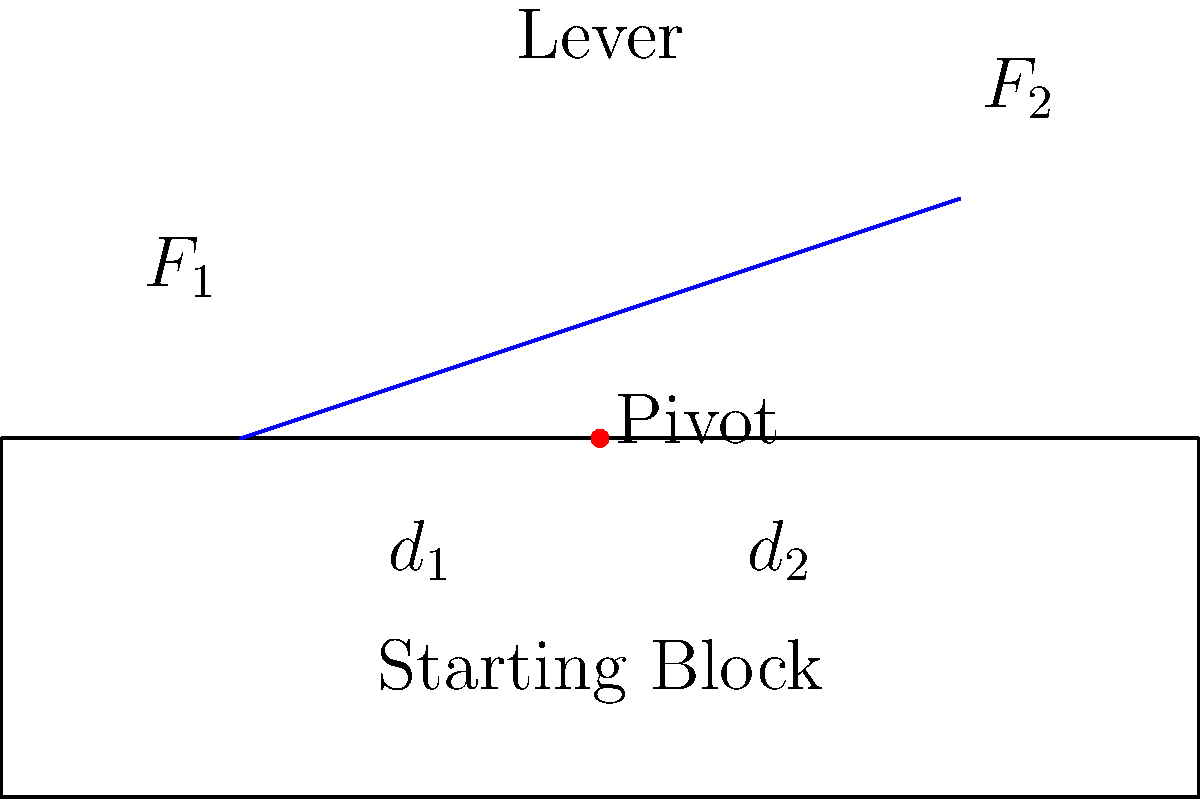A new starting block design for competitive swimming incorporates a lever mechanism to enhance the swimmer's push-off force. If the distance from the pivot to the swimmer's foot ($d_1$) is 30 cm and the distance from the pivot to the block's reaction point ($d_2$) is 50 cm, what force ($F_2$) must the starting block exert to balance a swimmer's push-off force ($F_1$) of 800 N? To solve this problem, we'll use the principle of mechanical advantage in a simple lever system:

1. The mechanical advantage of a lever is given by the ratio of the output force to the input force:
   $MA = \frac{F_2}{F_1} = \frac{d_1}{d_2}$

2. We are given:
   $F_1 = 800$ N (swimmer's push-off force)
   $d_1 = 30$ cm (distance from pivot to swimmer's foot)
   $d_2 = 50$ cm (distance from pivot to block's reaction point)

3. We need to find $F_2$ (force exerted by the starting block)

4. Rearranging the mechanical advantage equation:
   $\frac{F_2}{F_1} = \frac{d_1}{d_2}$

5. Cross multiply:
   $F_2 \cdot d_2 = F_1 \cdot d_1$

6. Solve for $F_2$:
   $F_2 = \frac{F_1 \cdot d_1}{d_2}$

7. Substitute the known values:
   $F_2 = \frac{800 \text{ N} \cdot 30 \text{ cm}}{50 \text{ cm}}$

8. Calculate:
   $F_2 = 480$ N

Therefore, the starting block must exert a force of 480 N to balance the swimmer's push-off force of 800 N.
Answer: 480 N 